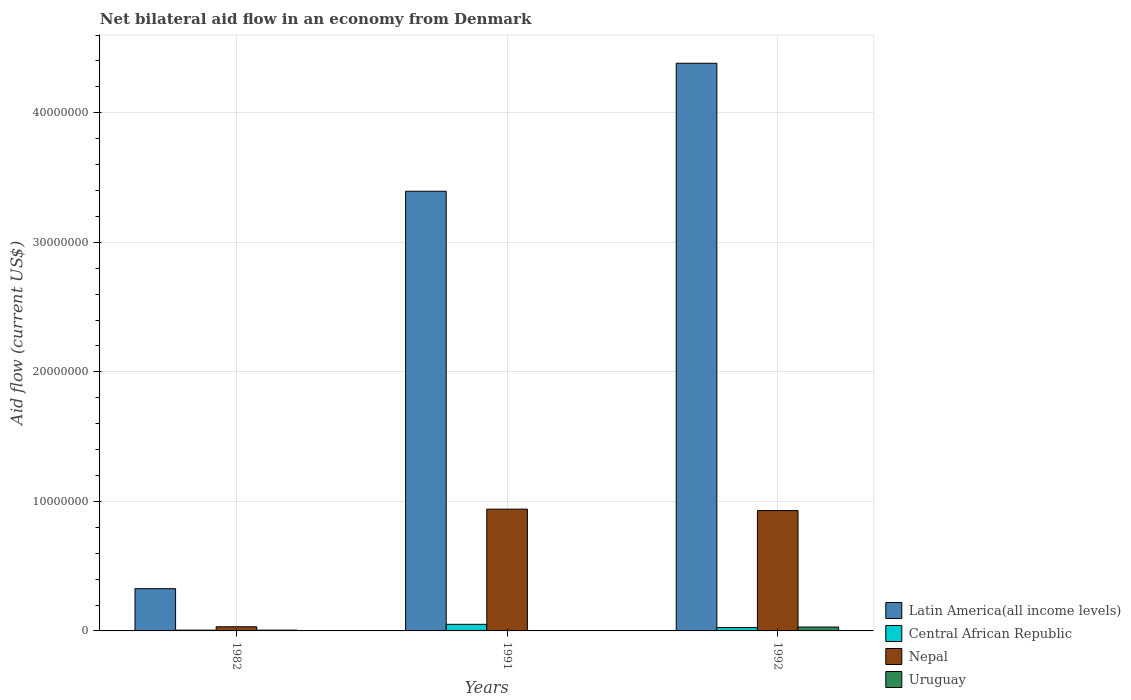Are the number of bars per tick equal to the number of legend labels?
Your response must be concise. Yes. How many bars are there on the 2nd tick from the left?
Offer a very short reply. 4. What is the label of the 2nd group of bars from the left?
Give a very brief answer. 1991. In how many cases, is the number of bars for a given year not equal to the number of legend labels?
Offer a very short reply. 0. What is the net bilateral aid flow in Uruguay in 1992?
Your answer should be compact. 3.00e+05. Across all years, what is the maximum net bilateral aid flow in Latin America(all income levels)?
Your response must be concise. 4.38e+07. What is the total net bilateral aid flow in Latin America(all income levels) in the graph?
Provide a succinct answer. 8.10e+07. What is the difference between the net bilateral aid flow in Latin America(all income levels) in 1992 and the net bilateral aid flow in Uruguay in 1991?
Make the answer very short. 4.38e+07. What is the average net bilateral aid flow in Nepal per year?
Ensure brevity in your answer.  6.34e+06. In the year 1982, what is the difference between the net bilateral aid flow in Latin America(all income levels) and net bilateral aid flow in Central African Republic?
Your response must be concise. 3.20e+06. What is the ratio of the net bilateral aid flow in Nepal in 1982 to that in 1992?
Your response must be concise. 0.03. What is the difference between the highest and the second highest net bilateral aid flow in Latin America(all income levels)?
Provide a short and direct response. 9.88e+06. Is the sum of the net bilateral aid flow in Uruguay in 1991 and 1992 greater than the maximum net bilateral aid flow in Nepal across all years?
Give a very brief answer. No. What does the 4th bar from the left in 1982 represents?
Provide a succinct answer. Uruguay. What does the 2nd bar from the right in 1992 represents?
Ensure brevity in your answer.  Nepal. How many bars are there?
Provide a succinct answer. 12. How many years are there in the graph?
Your response must be concise. 3. Are the values on the major ticks of Y-axis written in scientific E-notation?
Give a very brief answer. No. Does the graph contain any zero values?
Offer a terse response. No. Where does the legend appear in the graph?
Offer a terse response. Bottom right. How many legend labels are there?
Give a very brief answer. 4. What is the title of the graph?
Keep it short and to the point. Net bilateral aid flow in an economy from Denmark. Does "Belgium" appear as one of the legend labels in the graph?
Ensure brevity in your answer.  No. What is the label or title of the Y-axis?
Provide a succinct answer. Aid flow (current US$). What is the Aid flow (current US$) of Latin America(all income levels) in 1982?
Your answer should be very brief. 3.26e+06. What is the Aid flow (current US$) of Nepal in 1982?
Your response must be concise. 3.20e+05. What is the Aid flow (current US$) of Uruguay in 1982?
Provide a short and direct response. 6.00e+04. What is the Aid flow (current US$) of Latin America(all income levels) in 1991?
Provide a short and direct response. 3.39e+07. What is the Aid flow (current US$) of Central African Republic in 1991?
Provide a short and direct response. 5.10e+05. What is the Aid flow (current US$) of Nepal in 1991?
Your answer should be compact. 9.40e+06. What is the Aid flow (current US$) in Uruguay in 1991?
Provide a succinct answer. 3.00e+04. What is the Aid flow (current US$) in Latin America(all income levels) in 1992?
Ensure brevity in your answer.  4.38e+07. What is the Aid flow (current US$) in Nepal in 1992?
Offer a terse response. 9.29e+06. What is the Aid flow (current US$) in Uruguay in 1992?
Your answer should be compact. 3.00e+05. Across all years, what is the maximum Aid flow (current US$) of Latin America(all income levels)?
Offer a very short reply. 4.38e+07. Across all years, what is the maximum Aid flow (current US$) of Central African Republic?
Offer a terse response. 5.10e+05. Across all years, what is the maximum Aid flow (current US$) in Nepal?
Keep it short and to the point. 9.40e+06. Across all years, what is the maximum Aid flow (current US$) of Uruguay?
Provide a succinct answer. 3.00e+05. Across all years, what is the minimum Aid flow (current US$) in Latin America(all income levels)?
Your answer should be very brief. 3.26e+06. Across all years, what is the minimum Aid flow (current US$) in Central African Republic?
Provide a succinct answer. 6.00e+04. Across all years, what is the minimum Aid flow (current US$) of Nepal?
Your answer should be compact. 3.20e+05. What is the total Aid flow (current US$) in Latin America(all income levels) in the graph?
Ensure brevity in your answer.  8.10e+07. What is the total Aid flow (current US$) of Central African Republic in the graph?
Provide a short and direct response. 8.30e+05. What is the total Aid flow (current US$) in Nepal in the graph?
Provide a succinct answer. 1.90e+07. What is the total Aid flow (current US$) in Uruguay in the graph?
Ensure brevity in your answer.  3.90e+05. What is the difference between the Aid flow (current US$) in Latin America(all income levels) in 1982 and that in 1991?
Give a very brief answer. -3.07e+07. What is the difference between the Aid flow (current US$) in Central African Republic in 1982 and that in 1991?
Your response must be concise. -4.50e+05. What is the difference between the Aid flow (current US$) in Nepal in 1982 and that in 1991?
Provide a short and direct response. -9.08e+06. What is the difference between the Aid flow (current US$) of Latin America(all income levels) in 1982 and that in 1992?
Offer a very short reply. -4.06e+07. What is the difference between the Aid flow (current US$) of Central African Republic in 1982 and that in 1992?
Make the answer very short. -2.00e+05. What is the difference between the Aid flow (current US$) of Nepal in 1982 and that in 1992?
Keep it short and to the point. -8.97e+06. What is the difference between the Aid flow (current US$) of Uruguay in 1982 and that in 1992?
Offer a terse response. -2.40e+05. What is the difference between the Aid flow (current US$) in Latin America(all income levels) in 1991 and that in 1992?
Your response must be concise. -9.88e+06. What is the difference between the Aid flow (current US$) in Central African Republic in 1991 and that in 1992?
Provide a short and direct response. 2.50e+05. What is the difference between the Aid flow (current US$) of Nepal in 1991 and that in 1992?
Provide a short and direct response. 1.10e+05. What is the difference between the Aid flow (current US$) of Latin America(all income levels) in 1982 and the Aid flow (current US$) of Central African Republic in 1991?
Offer a very short reply. 2.75e+06. What is the difference between the Aid flow (current US$) of Latin America(all income levels) in 1982 and the Aid flow (current US$) of Nepal in 1991?
Make the answer very short. -6.14e+06. What is the difference between the Aid flow (current US$) of Latin America(all income levels) in 1982 and the Aid flow (current US$) of Uruguay in 1991?
Offer a terse response. 3.23e+06. What is the difference between the Aid flow (current US$) in Central African Republic in 1982 and the Aid flow (current US$) in Nepal in 1991?
Keep it short and to the point. -9.34e+06. What is the difference between the Aid flow (current US$) in Central African Republic in 1982 and the Aid flow (current US$) in Uruguay in 1991?
Your answer should be compact. 3.00e+04. What is the difference between the Aid flow (current US$) of Nepal in 1982 and the Aid flow (current US$) of Uruguay in 1991?
Provide a short and direct response. 2.90e+05. What is the difference between the Aid flow (current US$) in Latin America(all income levels) in 1982 and the Aid flow (current US$) in Central African Republic in 1992?
Your answer should be very brief. 3.00e+06. What is the difference between the Aid flow (current US$) of Latin America(all income levels) in 1982 and the Aid flow (current US$) of Nepal in 1992?
Your response must be concise. -6.03e+06. What is the difference between the Aid flow (current US$) in Latin America(all income levels) in 1982 and the Aid flow (current US$) in Uruguay in 1992?
Provide a short and direct response. 2.96e+06. What is the difference between the Aid flow (current US$) of Central African Republic in 1982 and the Aid flow (current US$) of Nepal in 1992?
Offer a terse response. -9.23e+06. What is the difference between the Aid flow (current US$) in Central African Republic in 1982 and the Aid flow (current US$) in Uruguay in 1992?
Ensure brevity in your answer.  -2.40e+05. What is the difference between the Aid flow (current US$) of Latin America(all income levels) in 1991 and the Aid flow (current US$) of Central African Republic in 1992?
Give a very brief answer. 3.37e+07. What is the difference between the Aid flow (current US$) in Latin America(all income levels) in 1991 and the Aid flow (current US$) in Nepal in 1992?
Offer a terse response. 2.46e+07. What is the difference between the Aid flow (current US$) in Latin America(all income levels) in 1991 and the Aid flow (current US$) in Uruguay in 1992?
Provide a short and direct response. 3.36e+07. What is the difference between the Aid flow (current US$) of Central African Republic in 1991 and the Aid flow (current US$) of Nepal in 1992?
Your answer should be very brief. -8.78e+06. What is the difference between the Aid flow (current US$) of Central African Republic in 1991 and the Aid flow (current US$) of Uruguay in 1992?
Provide a succinct answer. 2.10e+05. What is the difference between the Aid flow (current US$) in Nepal in 1991 and the Aid flow (current US$) in Uruguay in 1992?
Your response must be concise. 9.10e+06. What is the average Aid flow (current US$) in Latin America(all income levels) per year?
Provide a short and direct response. 2.70e+07. What is the average Aid flow (current US$) of Central African Republic per year?
Ensure brevity in your answer.  2.77e+05. What is the average Aid flow (current US$) of Nepal per year?
Offer a very short reply. 6.34e+06. What is the average Aid flow (current US$) in Uruguay per year?
Provide a succinct answer. 1.30e+05. In the year 1982, what is the difference between the Aid flow (current US$) in Latin America(all income levels) and Aid flow (current US$) in Central African Republic?
Your answer should be very brief. 3.20e+06. In the year 1982, what is the difference between the Aid flow (current US$) of Latin America(all income levels) and Aid flow (current US$) of Nepal?
Your response must be concise. 2.94e+06. In the year 1982, what is the difference between the Aid flow (current US$) in Latin America(all income levels) and Aid flow (current US$) in Uruguay?
Provide a succinct answer. 3.20e+06. In the year 1991, what is the difference between the Aid flow (current US$) of Latin America(all income levels) and Aid flow (current US$) of Central African Republic?
Offer a terse response. 3.34e+07. In the year 1991, what is the difference between the Aid flow (current US$) in Latin America(all income levels) and Aid flow (current US$) in Nepal?
Give a very brief answer. 2.45e+07. In the year 1991, what is the difference between the Aid flow (current US$) in Latin America(all income levels) and Aid flow (current US$) in Uruguay?
Make the answer very short. 3.39e+07. In the year 1991, what is the difference between the Aid flow (current US$) of Central African Republic and Aid flow (current US$) of Nepal?
Keep it short and to the point. -8.89e+06. In the year 1991, what is the difference between the Aid flow (current US$) of Central African Republic and Aid flow (current US$) of Uruguay?
Make the answer very short. 4.80e+05. In the year 1991, what is the difference between the Aid flow (current US$) of Nepal and Aid flow (current US$) of Uruguay?
Give a very brief answer. 9.37e+06. In the year 1992, what is the difference between the Aid flow (current US$) in Latin America(all income levels) and Aid flow (current US$) in Central African Republic?
Make the answer very short. 4.36e+07. In the year 1992, what is the difference between the Aid flow (current US$) of Latin America(all income levels) and Aid flow (current US$) of Nepal?
Your answer should be compact. 3.45e+07. In the year 1992, what is the difference between the Aid flow (current US$) of Latin America(all income levels) and Aid flow (current US$) of Uruguay?
Give a very brief answer. 4.35e+07. In the year 1992, what is the difference between the Aid flow (current US$) of Central African Republic and Aid flow (current US$) of Nepal?
Offer a terse response. -9.03e+06. In the year 1992, what is the difference between the Aid flow (current US$) of Central African Republic and Aid flow (current US$) of Uruguay?
Make the answer very short. -4.00e+04. In the year 1992, what is the difference between the Aid flow (current US$) of Nepal and Aid flow (current US$) of Uruguay?
Keep it short and to the point. 8.99e+06. What is the ratio of the Aid flow (current US$) in Latin America(all income levels) in 1982 to that in 1991?
Offer a very short reply. 0.1. What is the ratio of the Aid flow (current US$) in Central African Republic in 1982 to that in 1991?
Your answer should be very brief. 0.12. What is the ratio of the Aid flow (current US$) in Nepal in 1982 to that in 1991?
Your response must be concise. 0.03. What is the ratio of the Aid flow (current US$) in Latin America(all income levels) in 1982 to that in 1992?
Your answer should be very brief. 0.07. What is the ratio of the Aid flow (current US$) in Central African Republic in 1982 to that in 1992?
Offer a terse response. 0.23. What is the ratio of the Aid flow (current US$) of Nepal in 1982 to that in 1992?
Offer a terse response. 0.03. What is the ratio of the Aid flow (current US$) in Uruguay in 1982 to that in 1992?
Make the answer very short. 0.2. What is the ratio of the Aid flow (current US$) of Latin America(all income levels) in 1991 to that in 1992?
Your response must be concise. 0.77. What is the ratio of the Aid flow (current US$) in Central African Republic in 1991 to that in 1992?
Give a very brief answer. 1.96. What is the ratio of the Aid flow (current US$) in Nepal in 1991 to that in 1992?
Your answer should be compact. 1.01. What is the ratio of the Aid flow (current US$) in Uruguay in 1991 to that in 1992?
Your answer should be very brief. 0.1. What is the difference between the highest and the second highest Aid flow (current US$) of Latin America(all income levels)?
Offer a very short reply. 9.88e+06. What is the difference between the highest and the second highest Aid flow (current US$) in Nepal?
Your response must be concise. 1.10e+05. What is the difference between the highest and the second highest Aid flow (current US$) of Uruguay?
Your answer should be very brief. 2.40e+05. What is the difference between the highest and the lowest Aid flow (current US$) in Latin America(all income levels)?
Ensure brevity in your answer.  4.06e+07. What is the difference between the highest and the lowest Aid flow (current US$) of Central African Republic?
Your answer should be compact. 4.50e+05. What is the difference between the highest and the lowest Aid flow (current US$) in Nepal?
Provide a short and direct response. 9.08e+06. 